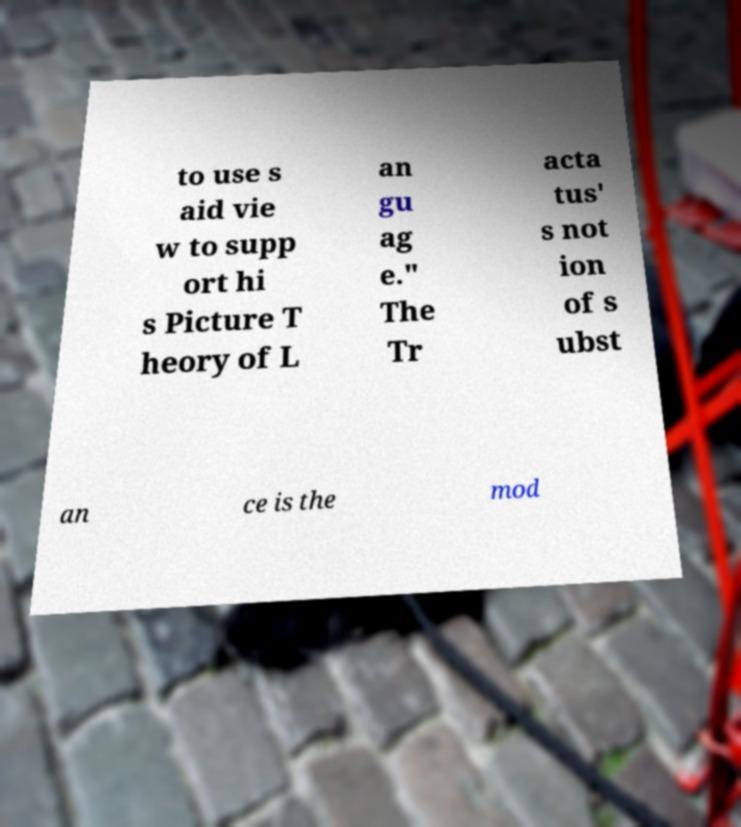Can you accurately transcribe the text from the provided image for me? to use s aid vie w to supp ort hi s Picture T heory of L an gu ag e." The Tr acta tus' s not ion of s ubst an ce is the mod 